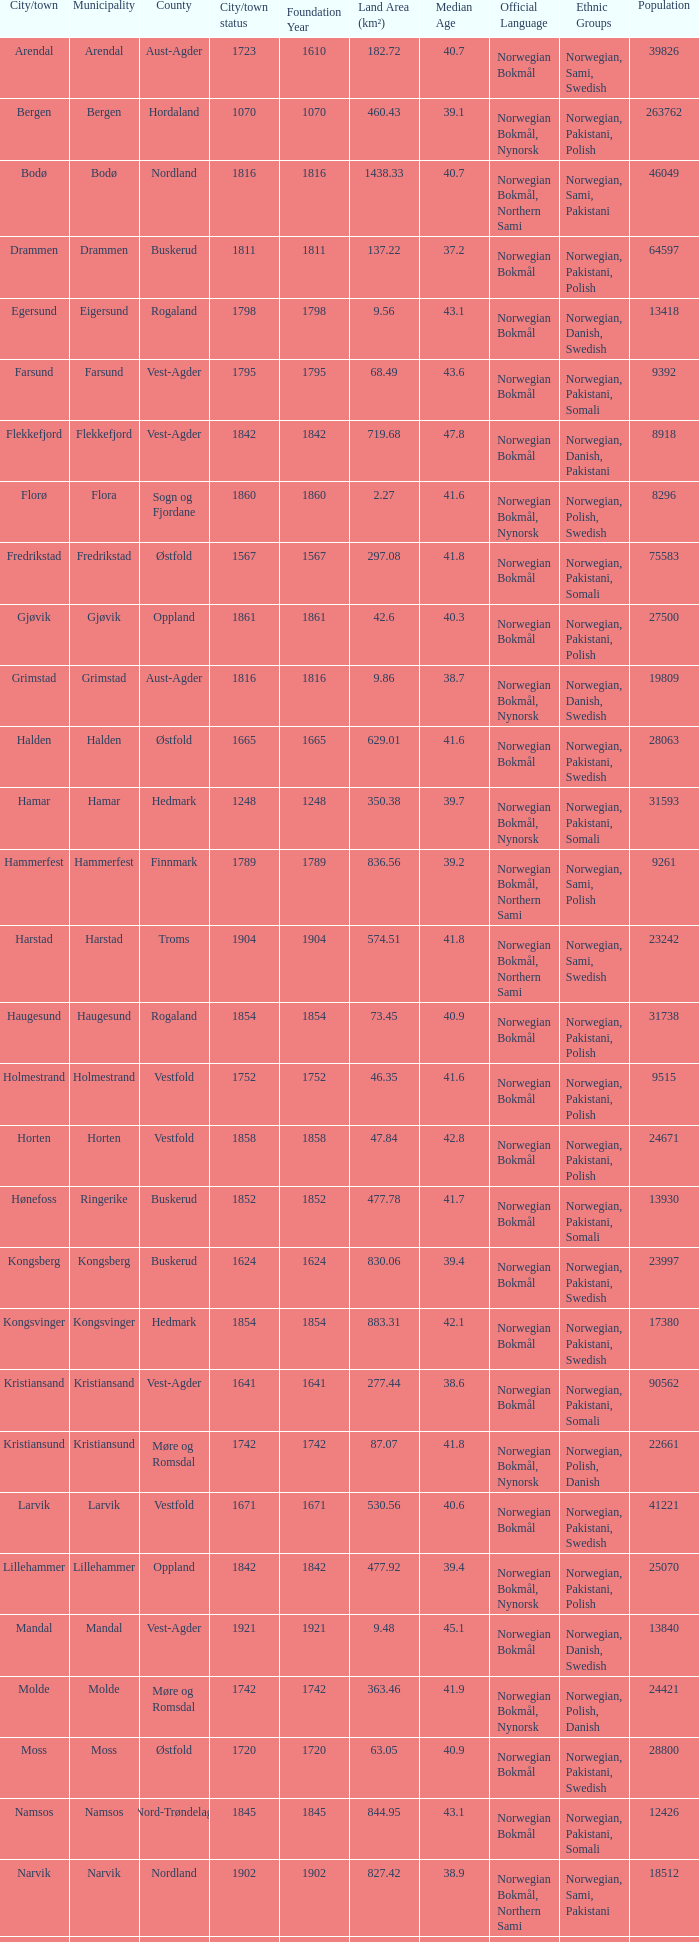What is the total population in the city/town of Arendal? 1.0. 